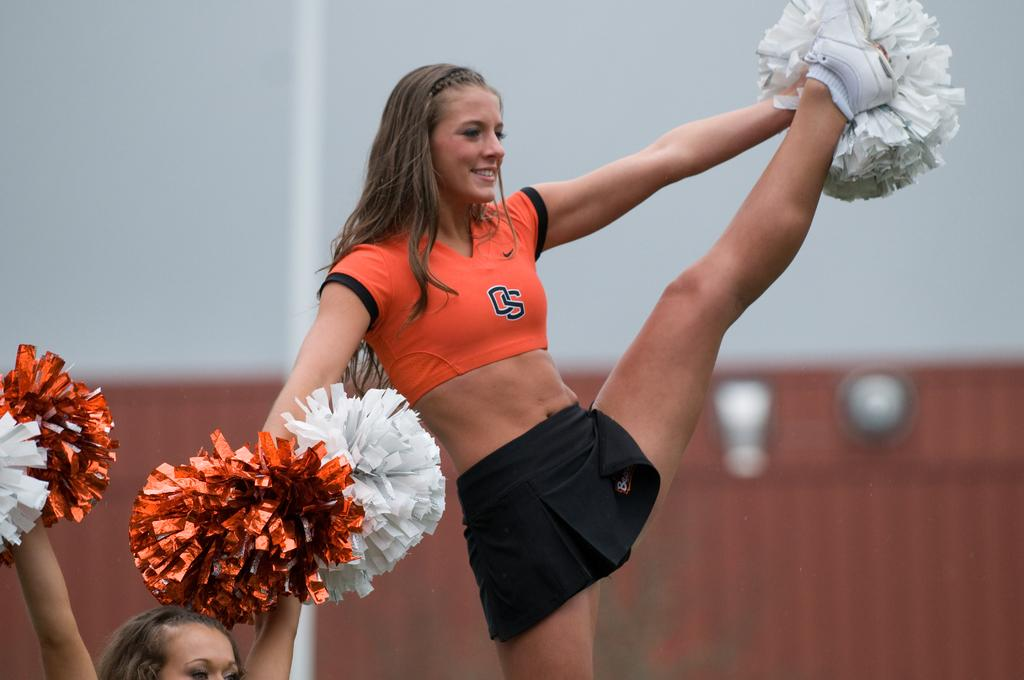<image>
Summarize the visual content of the image. A cheerleader in an orange top bearing the initials OS kicks her left leg high into the air whilst holding pom poms. 